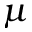Convert formula to latex. <formula><loc_0><loc_0><loc_500><loc_500>\mu</formula> 